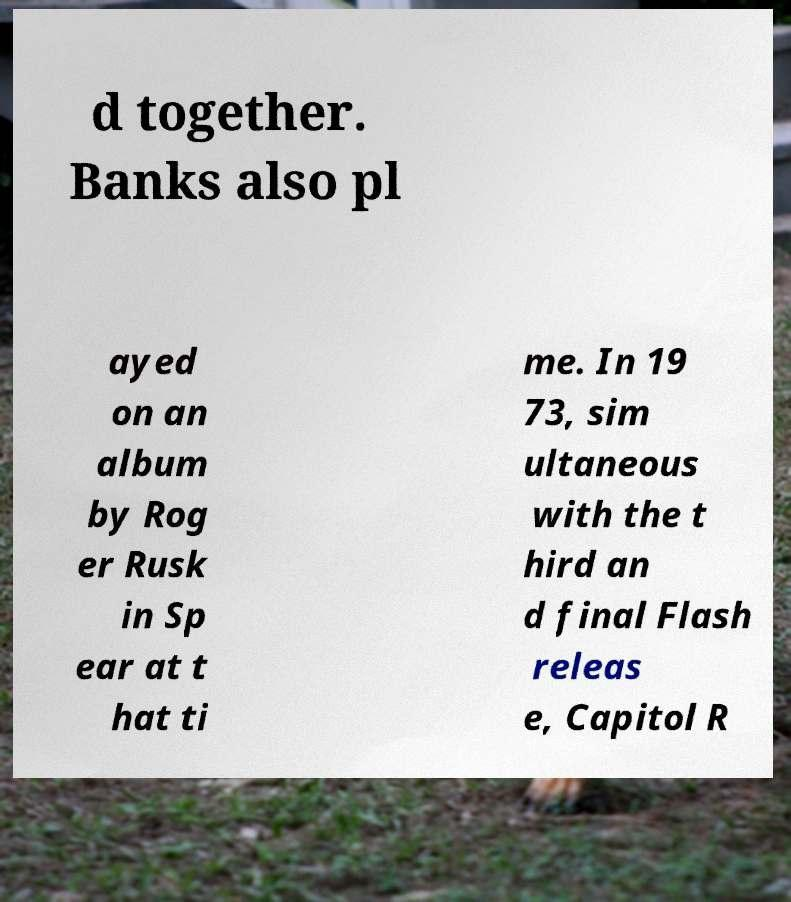Could you assist in decoding the text presented in this image and type it out clearly? d together. Banks also pl ayed on an album by Rog er Rusk in Sp ear at t hat ti me. In 19 73, sim ultaneous with the t hird an d final Flash releas e, Capitol R 